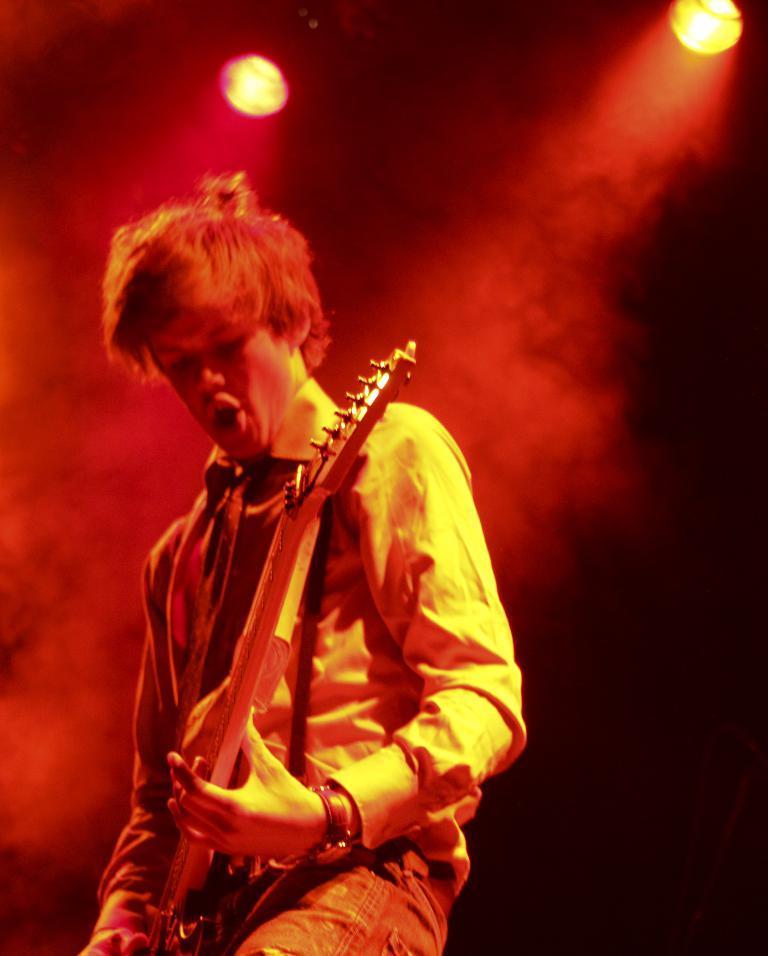Please provide a concise description of this image. In the image we can see a man standing, wearing clothes and a wrist watch. This is a guitar, smoke and lights. 